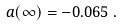Convert formula to latex. <formula><loc_0><loc_0><loc_500><loc_500>a ( \infty ) = - 0 . 0 6 5 \, .</formula> 